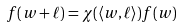<formula> <loc_0><loc_0><loc_500><loc_500>f ( w + \ell ) = \chi ( \langle w , \ell \rangle ) f ( w )</formula> 